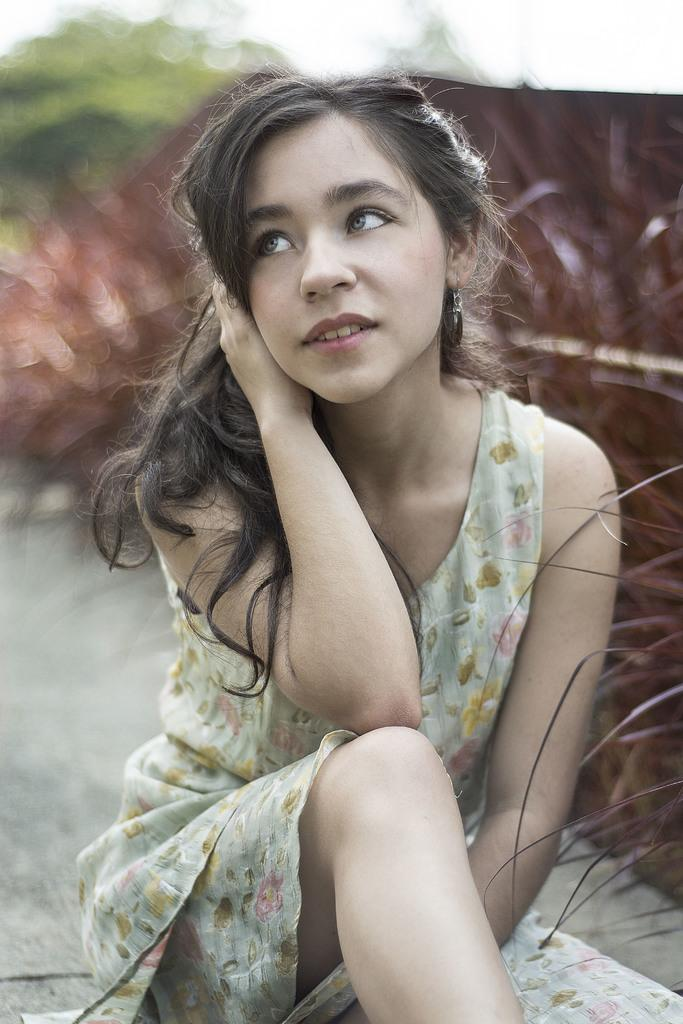What is the main subject in the front of the image? There is a girl sitting in the front of the image. What can be seen in the background of the image? There is a tree in the background of the image. How would you describe the background of the image? The background of the image appears blurry. What type of vegetation is visible on the right side of the image? There are leaves of a plant visible on the right side of the image. What is the price of the rule in the image? There is no rule or price mentioned in the image. 